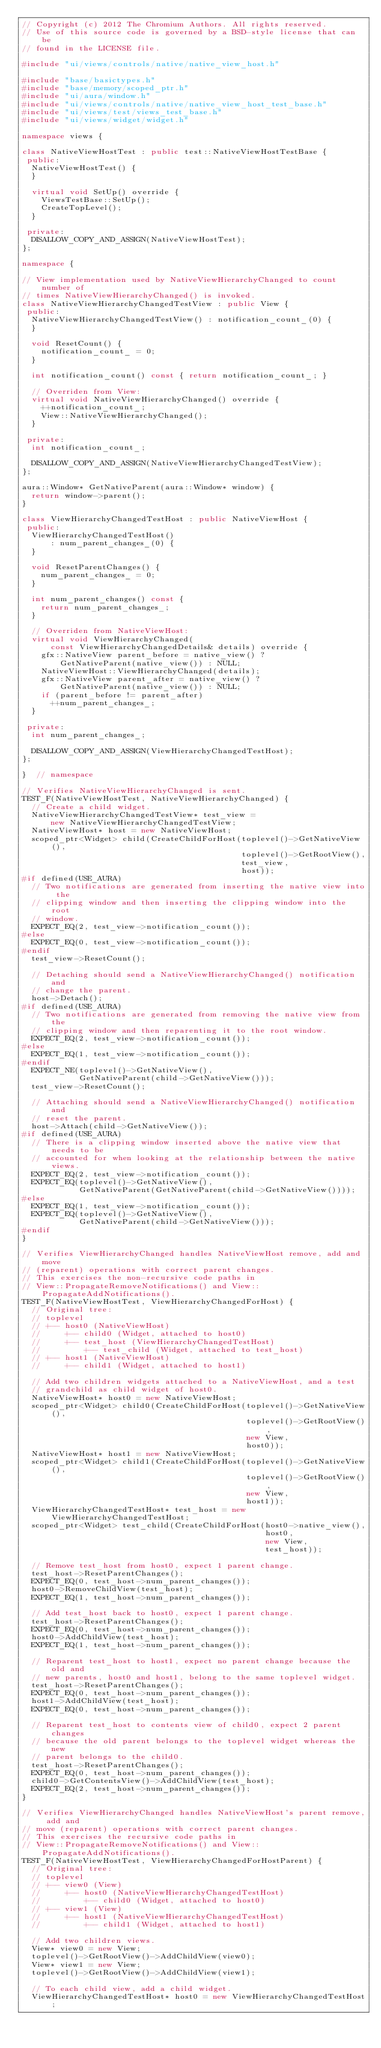<code> <loc_0><loc_0><loc_500><loc_500><_C++_>// Copyright (c) 2012 The Chromium Authors. All rights reserved.
// Use of this source code is governed by a BSD-style license that can be
// found in the LICENSE file.

#include "ui/views/controls/native/native_view_host.h"

#include "base/basictypes.h"
#include "base/memory/scoped_ptr.h"
#include "ui/aura/window.h"
#include "ui/views/controls/native/native_view_host_test_base.h"
#include "ui/views/test/views_test_base.h"
#include "ui/views/widget/widget.h"

namespace views {

class NativeViewHostTest : public test::NativeViewHostTestBase {
 public:
  NativeViewHostTest() {
  }

  virtual void SetUp() override {
    ViewsTestBase::SetUp();
    CreateTopLevel();
  }

 private:
  DISALLOW_COPY_AND_ASSIGN(NativeViewHostTest);
};

namespace {

// View implementation used by NativeViewHierarchyChanged to count number of
// times NativeViewHierarchyChanged() is invoked.
class NativeViewHierarchyChangedTestView : public View {
 public:
  NativeViewHierarchyChangedTestView() : notification_count_(0) {
  }

  void ResetCount() {
    notification_count_ = 0;
  }

  int notification_count() const { return notification_count_; }

  // Overriden from View:
  virtual void NativeViewHierarchyChanged() override {
    ++notification_count_;
    View::NativeViewHierarchyChanged();
  }

 private:
  int notification_count_;

  DISALLOW_COPY_AND_ASSIGN(NativeViewHierarchyChangedTestView);
};

aura::Window* GetNativeParent(aura::Window* window) {
  return window->parent();
}

class ViewHierarchyChangedTestHost : public NativeViewHost {
 public:
  ViewHierarchyChangedTestHost()
      : num_parent_changes_(0) {
  }

  void ResetParentChanges() {
    num_parent_changes_ = 0;
  }

  int num_parent_changes() const {
    return num_parent_changes_;
  }

  // Overriden from NativeViewHost:
  virtual void ViewHierarchyChanged(
      const ViewHierarchyChangedDetails& details) override {
    gfx::NativeView parent_before = native_view() ?
        GetNativeParent(native_view()) : NULL;
    NativeViewHost::ViewHierarchyChanged(details);
    gfx::NativeView parent_after = native_view() ?
        GetNativeParent(native_view()) : NULL;
    if (parent_before != parent_after)
      ++num_parent_changes_;
  }

 private:
  int num_parent_changes_;

  DISALLOW_COPY_AND_ASSIGN(ViewHierarchyChangedTestHost);
};

}  // namespace

// Verifies NativeViewHierarchyChanged is sent.
TEST_F(NativeViewHostTest, NativeViewHierarchyChanged) {
  // Create a child widget.
  NativeViewHierarchyChangedTestView* test_view =
      new NativeViewHierarchyChangedTestView;
  NativeViewHost* host = new NativeViewHost;
  scoped_ptr<Widget> child(CreateChildForHost(toplevel()->GetNativeView(),
                                              toplevel()->GetRootView(),
                                              test_view,
                                              host));
#if defined(USE_AURA)
  // Two notifications are generated from inserting the native view into the
  // clipping window and then inserting the clipping window into the root
  // window.
  EXPECT_EQ(2, test_view->notification_count());
#else
  EXPECT_EQ(0, test_view->notification_count());
#endif
  test_view->ResetCount();

  // Detaching should send a NativeViewHierarchyChanged() notification and
  // change the parent.
  host->Detach();
#if defined(USE_AURA)
  // Two notifications are generated from removing the native view from the
  // clipping window and then reparenting it to the root window.
  EXPECT_EQ(2, test_view->notification_count());
#else
  EXPECT_EQ(1, test_view->notification_count());
#endif
  EXPECT_NE(toplevel()->GetNativeView(),
            GetNativeParent(child->GetNativeView()));
  test_view->ResetCount();

  // Attaching should send a NativeViewHierarchyChanged() notification and
  // reset the parent.
  host->Attach(child->GetNativeView());
#if defined(USE_AURA)
  // There is a clipping window inserted above the native view that needs to be
  // accounted for when looking at the relationship between the native views.
  EXPECT_EQ(2, test_view->notification_count());
  EXPECT_EQ(toplevel()->GetNativeView(),
            GetNativeParent(GetNativeParent(child->GetNativeView())));
#else
  EXPECT_EQ(1, test_view->notification_count());
  EXPECT_EQ(toplevel()->GetNativeView(),
            GetNativeParent(child->GetNativeView()));
#endif
}

// Verifies ViewHierarchyChanged handles NativeViewHost remove, add and move
// (reparent) operations with correct parent changes.
// This exercises the non-recursive code paths in
// View::PropagateRemoveNotifications() and View::PropagateAddNotifications().
TEST_F(NativeViewHostTest, ViewHierarchyChangedForHost) {
  // Original tree:
  // toplevel
  // +-- host0 (NativeViewHost)
  //     +-- child0 (Widget, attached to host0)
  //     +-- test_host (ViewHierarchyChangedTestHost)
  //         +-- test_child (Widget, attached to test_host)
  // +-- host1 (NativeViewHost)
  //     +-- child1 (Widget, attached to host1)

  // Add two children widgets attached to a NativeViewHost, and a test
  // grandchild as child widget of host0.
  NativeViewHost* host0 = new NativeViewHost;
  scoped_ptr<Widget> child0(CreateChildForHost(toplevel()->GetNativeView(),
                                               toplevel()->GetRootView(),
                                               new View,
                                               host0));
  NativeViewHost* host1 = new NativeViewHost;
  scoped_ptr<Widget> child1(CreateChildForHost(toplevel()->GetNativeView(),
                                               toplevel()->GetRootView(),
                                               new View,
                                               host1));
  ViewHierarchyChangedTestHost* test_host = new ViewHierarchyChangedTestHost;
  scoped_ptr<Widget> test_child(CreateChildForHost(host0->native_view(),
                                                   host0,
                                                   new View,
                                                   test_host));

  // Remove test_host from host0, expect 1 parent change.
  test_host->ResetParentChanges();
  EXPECT_EQ(0, test_host->num_parent_changes());
  host0->RemoveChildView(test_host);
  EXPECT_EQ(1, test_host->num_parent_changes());

  // Add test_host back to host0, expect 1 parent change.
  test_host->ResetParentChanges();
  EXPECT_EQ(0, test_host->num_parent_changes());
  host0->AddChildView(test_host);
  EXPECT_EQ(1, test_host->num_parent_changes());

  // Reparent test_host to host1, expect no parent change because the old and
  // new parents, host0 and host1, belong to the same toplevel widget.
  test_host->ResetParentChanges();
  EXPECT_EQ(0, test_host->num_parent_changes());
  host1->AddChildView(test_host);
  EXPECT_EQ(0, test_host->num_parent_changes());

  // Reparent test_host to contents view of child0, expect 2 parent changes
  // because the old parent belongs to the toplevel widget whereas the new
  // parent belongs to the child0.
  test_host->ResetParentChanges();
  EXPECT_EQ(0, test_host->num_parent_changes());
  child0->GetContentsView()->AddChildView(test_host);
  EXPECT_EQ(2, test_host->num_parent_changes());
}

// Verifies ViewHierarchyChanged handles NativeViewHost's parent remove, add and
// move (reparent) operations with correct parent changes.
// This exercises the recursive code paths in
// View::PropagateRemoveNotifications() and View::PropagateAddNotifications().
TEST_F(NativeViewHostTest, ViewHierarchyChangedForHostParent) {
  // Original tree:
  // toplevel
  // +-- view0 (View)
  //     +-- host0 (NativeViewHierarchyChangedTestHost)
  //         +-- child0 (Widget, attached to host0)
  // +-- view1 (View)
  //     +-- host1 (NativeViewHierarchyChangedTestHost)
  //         +-- child1 (Widget, attached to host1)

  // Add two children views.
  View* view0 = new View;
  toplevel()->GetRootView()->AddChildView(view0);
  View* view1 = new View;
  toplevel()->GetRootView()->AddChildView(view1);

  // To each child view, add a child widget.
  ViewHierarchyChangedTestHost* host0 = new ViewHierarchyChangedTestHost;</code> 